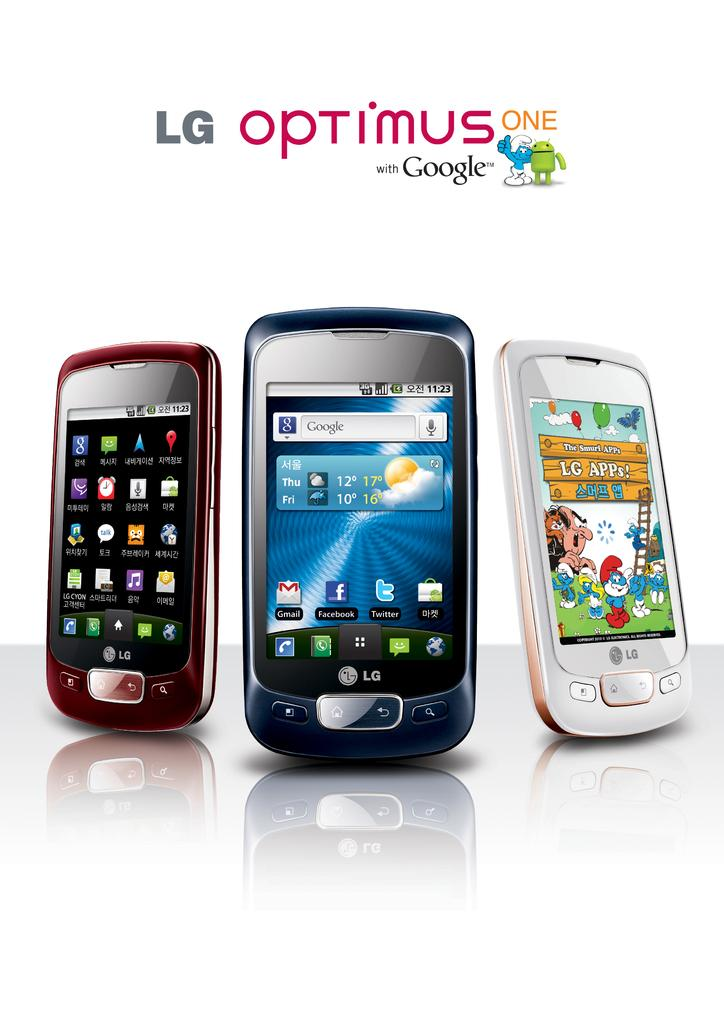<image>
Write a terse but informative summary of the picture. The three LG phones shown come with Google. 